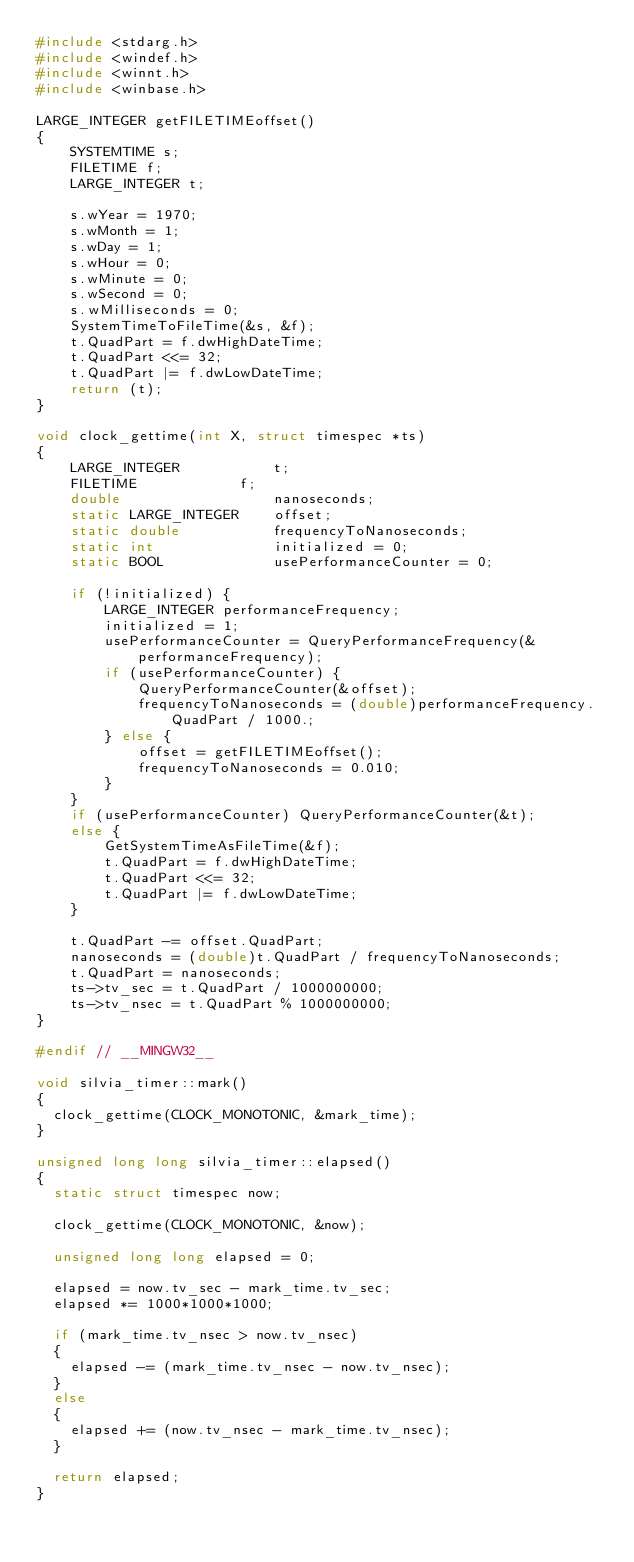<code> <loc_0><loc_0><loc_500><loc_500><_C++_>#include <stdarg.h>
#include <windef.h>
#include <winnt.h>
#include <winbase.h>

LARGE_INTEGER getFILETIMEoffset()
{
    SYSTEMTIME s;
    FILETIME f;
    LARGE_INTEGER t;

    s.wYear = 1970;
    s.wMonth = 1;
    s.wDay = 1;
    s.wHour = 0;
    s.wMinute = 0;
    s.wSecond = 0;
    s.wMilliseconds = 0;
    SystemTimeToFileTime(&s, &f);
    t.QuadPart = f.dwHighDateTime;
    t.QuadPart <<= 32;
    t.QuadPart |= f.dwLowDateTime;
    return (t);
}

void clock_gettime(int X, struct timespec *ts)
{
    LARGE_INTEGER           t;
    FILETIME            f;
    double                  nanoseconds;
    static LARGE_INTEGER    offset;
    static double           frequencyToNanoseconds;
    static int              initialized = 0;
    static BOOL             usePerformanceCounter = 0;

    if (!initialized) {
        LARGE_INTEGER performanceFrequency;
        initialized = 1;
        usePerformanceCounter = QueryPerformanceFrequency(&performanceFrequency);
        if (usePerformanceCounter) {
            QueryPerformanceCounter(&offset);
            frequencyToNanoseconds = (double)performanceFrequency.QuadPart / 1000.;
        } else {
            offset = getFILETIMEoffset();
            frequencyToNanoseconds = 0.010;
        }
    }
    if (usePerformanceCounter) QueryPerformanceCounter(&t);
    else {
        GetSystemTimeAsFileTime(&f);
        t.QuadPart = f.dwHighDateTime;
        t.QuadPart <<= 32;
        t.QuadPart |= f.dwLowDateTime;
    }

    t.QuadPart -= offset.QuadPart;
    nanoseconds = (double)t.QuadPart / frequencyToNanoseconds;
    t.QuadPart = nanoseconds;
    ts->tv_sec = t.QuadPart / 1000000000;
    ts->tv_nsec = t.QuadPart % 1000000000;
}

#endif // __MINGW32__

void silvia_timer::mark()
{
	clock_gettime(CLOCK_MONOTONIC, &mark_time);
}
	
unsigned long long silvia_timer::elapsed()
{
	static struct timespec now;
	
	clock_gettime(CLOCK_MONOTONIC, &now);
	
	unsigned long long elapsed = 0;
	
	elapsed = now.tv_sec - mark_time.tv_sec;
	elapsed *= 1000*1000*1000;
	
	if (mark_time.tv_nsec > now.tv_nsec)
	{
		elapsed -= (mark_time.tv_nsec - now.tv_nsec);
	}
	else
	{
		elapsed += (now.tv_nsec - mark_time.tv_nsec);
	}
	
	return elapsed;
}
</code> 